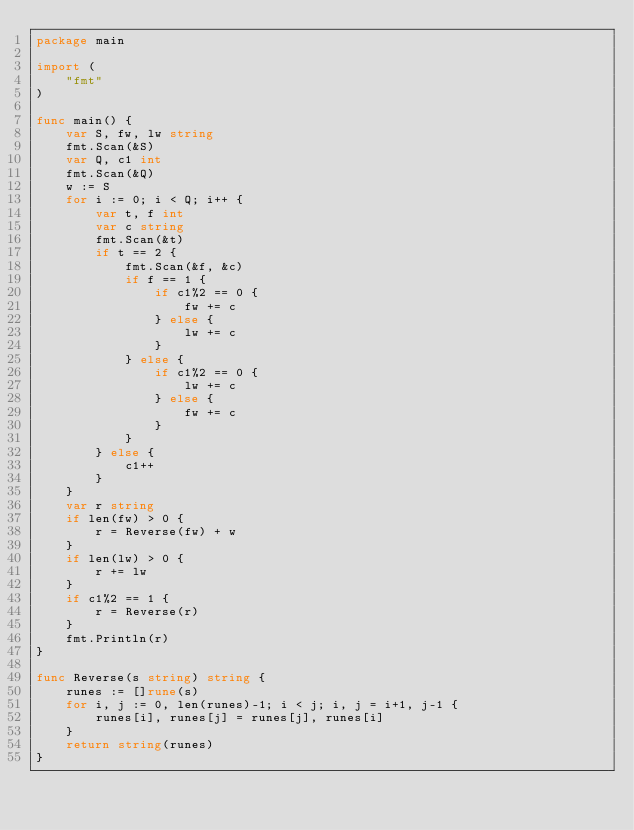<code> <loc_0><loc_0><loc_500><loc_500><_Go_>package main

import (
	"fmt"
)

func main() {
	var S, fw, lw string
	fmt.Scan(&S)
	var Q, c1 int
	fmt.Scan(&Q)
	w := S
	for i := 0; i < Q; i++ {
		var t, f int
		var c string
		fmt.Scan(&t)
		if t == 2 {
			fmt.Scan(&f, &c)
			if f == 1 {
				if c1%2 == 0 {
					fw += c
				} else {
					lw += c
				}
			} else {
				if c1%2 == 0 {
					lw += c
				} else {
					fw += c
				}
			}
		} else {
			c1++
		}
	}
	var r string
	if len(fw) > 0 {
		r = Reverse(fw) + w 
	}
	if len(lw) > 0 {
		r += lw	
	}
	if c1%2 == 1 {
		r = Reverse(r)
	}
	fmt.Println(r)
}

func Reverse(s string) string {
	runes := []rune(s)
	for i, j := 0, len(runes)-1; i < j; i, j = i+1, j-1 {
		runes[i], runes[j] = runes[j], runes[i]
	}
	return string(runes)
}
</code> 